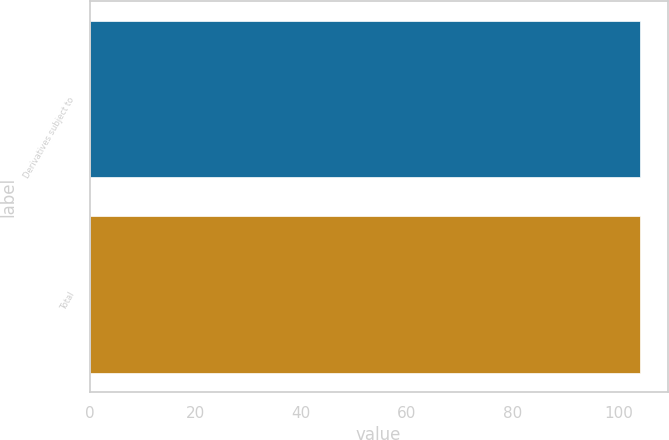Convert chart to OTSL. <chart><loc_0><loc_0><loc_500><loc_500><bar_chart><fcel>Derivatives subject to<fcel>Total<nl><fcel>104<fcel>104.1<nl></chart> 